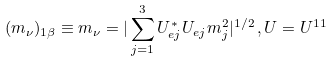<formula> <loc_0><loc_0><loc_500><loc_500>( m _ { \nu } ) _ { 1 \beta } \equiv m _ { \nu } = | \sum _ { j = 1 } ^ { 3 } U ^ { * } _ { e j } U _ { e j } m ^ { 2 } _ { j } | ^ { 1 / 2 } \, , U = U ^ { 1 1 }</formula> 